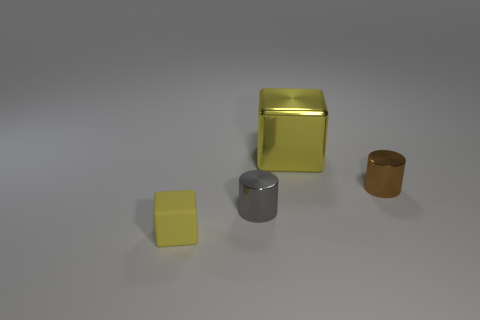Can you describe the positioning of objects in the image? Certainly! The image shows a neatly arranged group of four objects at different distances from the viewer's perspective. There's a yellow cube and a silver cylindrical object in the foreground, which are closest to the viewer. Behind them and slightly to the right is a golden cuboid, and further back to the right there's a small matte brown cylinder. They are all placed on what appears to be a flat, reflective surface. 